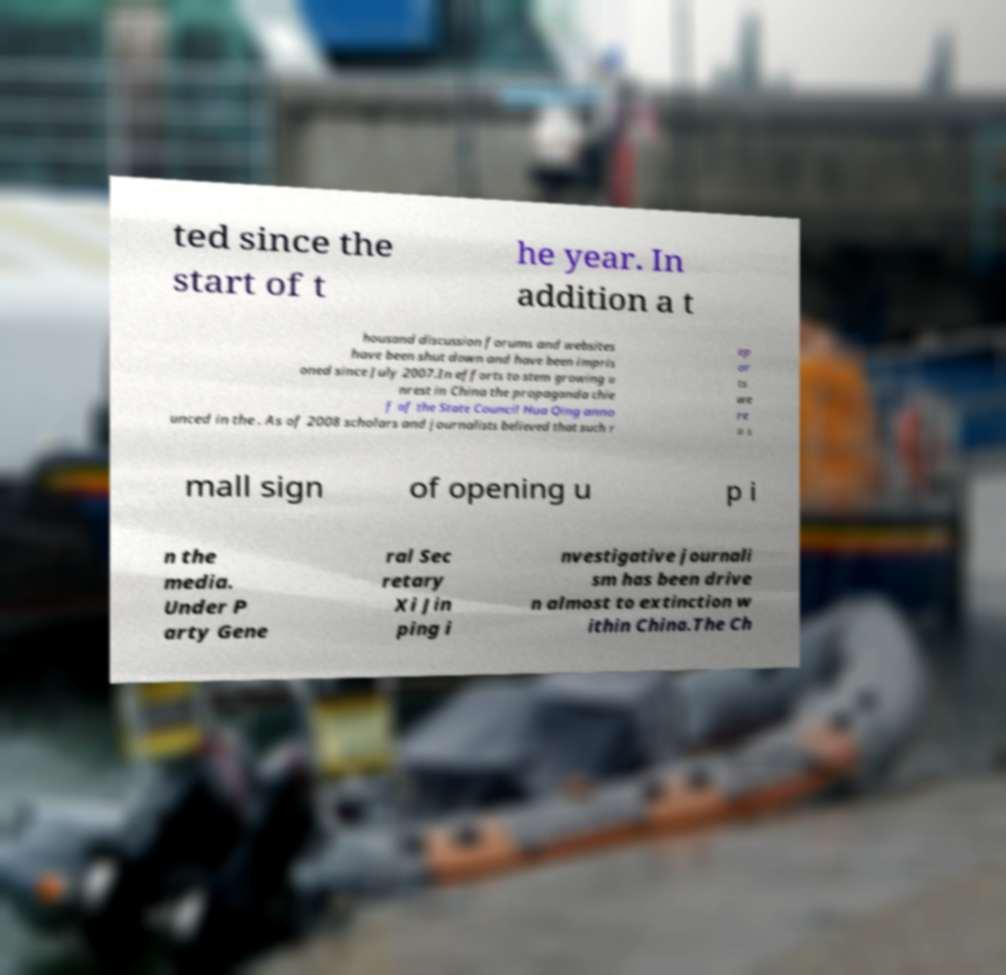Please identify and transcribe the text found in this image. ted since the start of t he year. In addition a t housand discussion forums and websites have been shut down and have been impris oned since July 2007.In efforts to stem growing u nrest in China the propaganda chie f of the State Council Hua Qing anno unced in the . As of 2008 scholars and journalists believed that such r ep or ts we re a s mall sign of opening u p i n the media. Under P arty Gene ral Sec retary Xi Jin ping i nvestigative journali sm has been drive n almost to extinction w ithin China.The Ch 